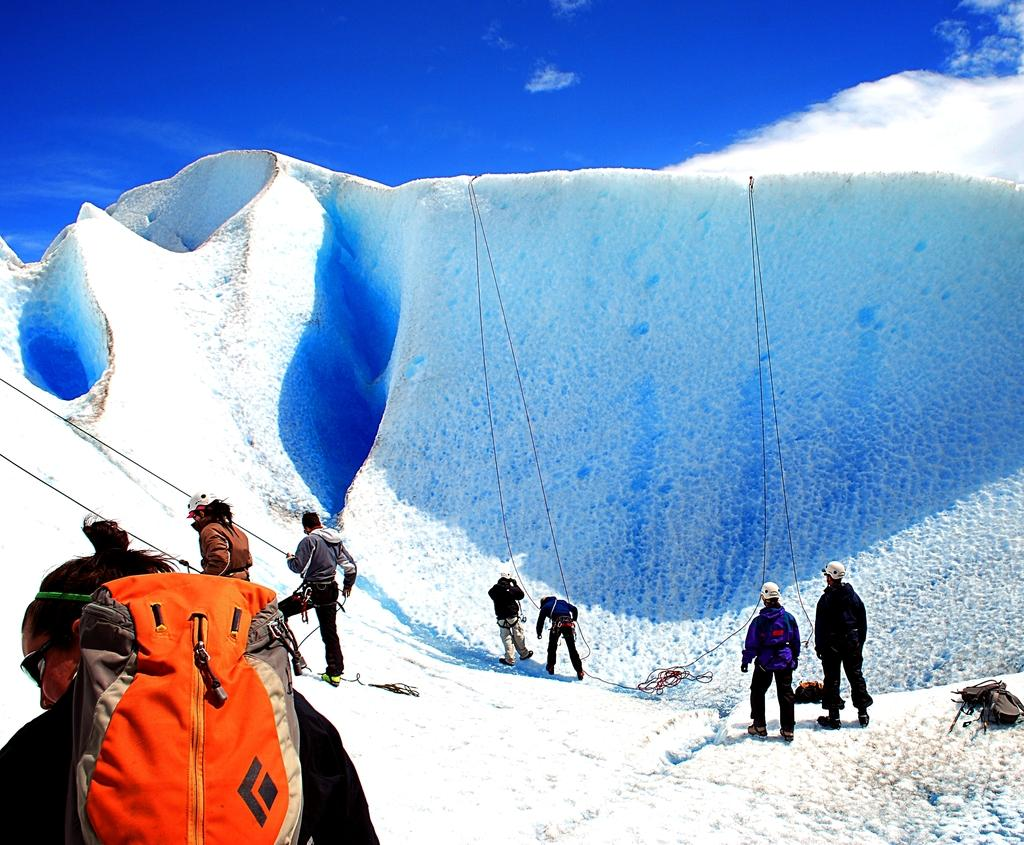What is happening in the image involving a group of people? The people in the image are getting ready for hiking. What is the condition of the area where the people are hiking? The area is covered with snow. What can be seen in the background of the image? There is a sky visible in the background of the image. What type of care can be seen being provided to the books in the image? There are no books present in the image, so no care is being provided to them. What is the pail being used for in the image? There is no pail present in the image, so it cannot be used for anything. 